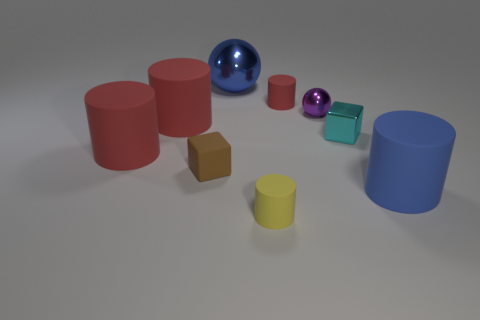How many red cylinders must be subtracted to get 1 red cylinders? 2 Subtract all red spheres. How many red cylinders are left? 3 Subtract all small yellow cylinders. How many cylinders are left? 4 Subtract all blue cylinders. How many cylinders are left? 4 Subtract all brown cylinders. Subtract all red cubes. How many cylinders are left? 5 Add 1 tiny cyan objects. How many objects exist? 10 Subtract all cylinders. How many objects are left? 4 Subtract all large red blocks. Subtract all large blue things. How many objects are left? 7 Add 2 small purple shiny objects. How many small purple shiny objects are left? 3 Add 2 big red spheres. How many big red spheres exist? 2 